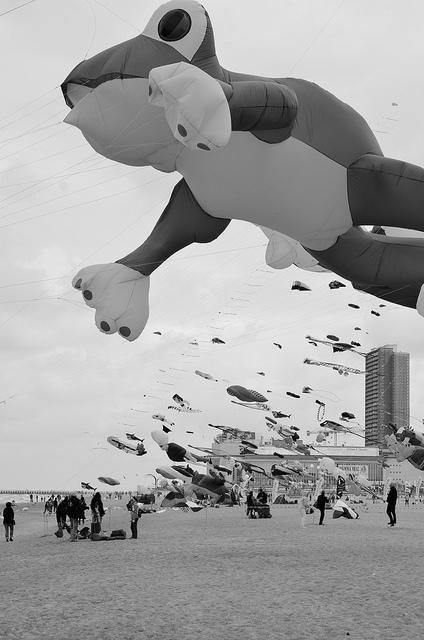How many kites are there?
Give a very brief answer. 2. 